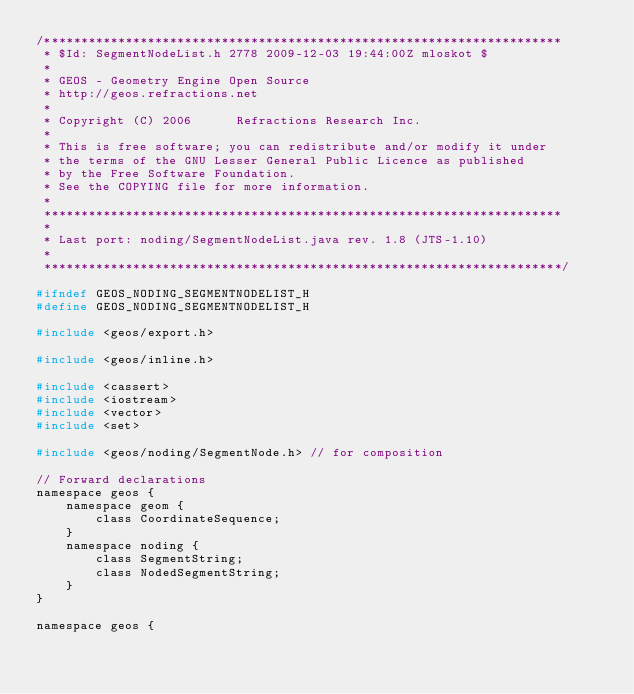Convert code to text. <code><loc_0><loc_0><loc_500><loc_500><_C_>/**********************************************************************
 * $Id: SegmentNodeList.h 2778 2009-12-03 19:44:00Z mloskot $
 *
 * GEOS - Geometry Engine Open Source
 * http://geos.refractions.net
 *
 * Copyright (C) 2006      Refractions Research Inc.
 *
 * This is free software; you can redistribute and/or modify it under
 * the terms of the GNU Lesser General Public Licence as published
 * by the Free Software Foundation. 
 * See the COPYING file for more information.
 *
 **********************************************************************
 *
 * Last port: noding/SegmentNodeList.java rev. 1.8 (JTS-1.10)
 *
 **********************************************************************/

#ifndef GEOS_NODING_SEGMENTNODELIST_H
#define GEOS_NODING_SEGMENTNODELIST_H

#include <geos/export.h>

#include <geos/inline.h>

#include <cassert>
#include <iostream>
#include <vector>
#include <set>

#include <geos/noding/SegmentNode.h> // for composition

// Forward declarations
namespace geos {
	namespace geom {
		class CoordinateSequence;
	}
	namespace noding {
		class SegmentString;
		class NodedSegmentString;
	}
}

namespace geos {</code> 